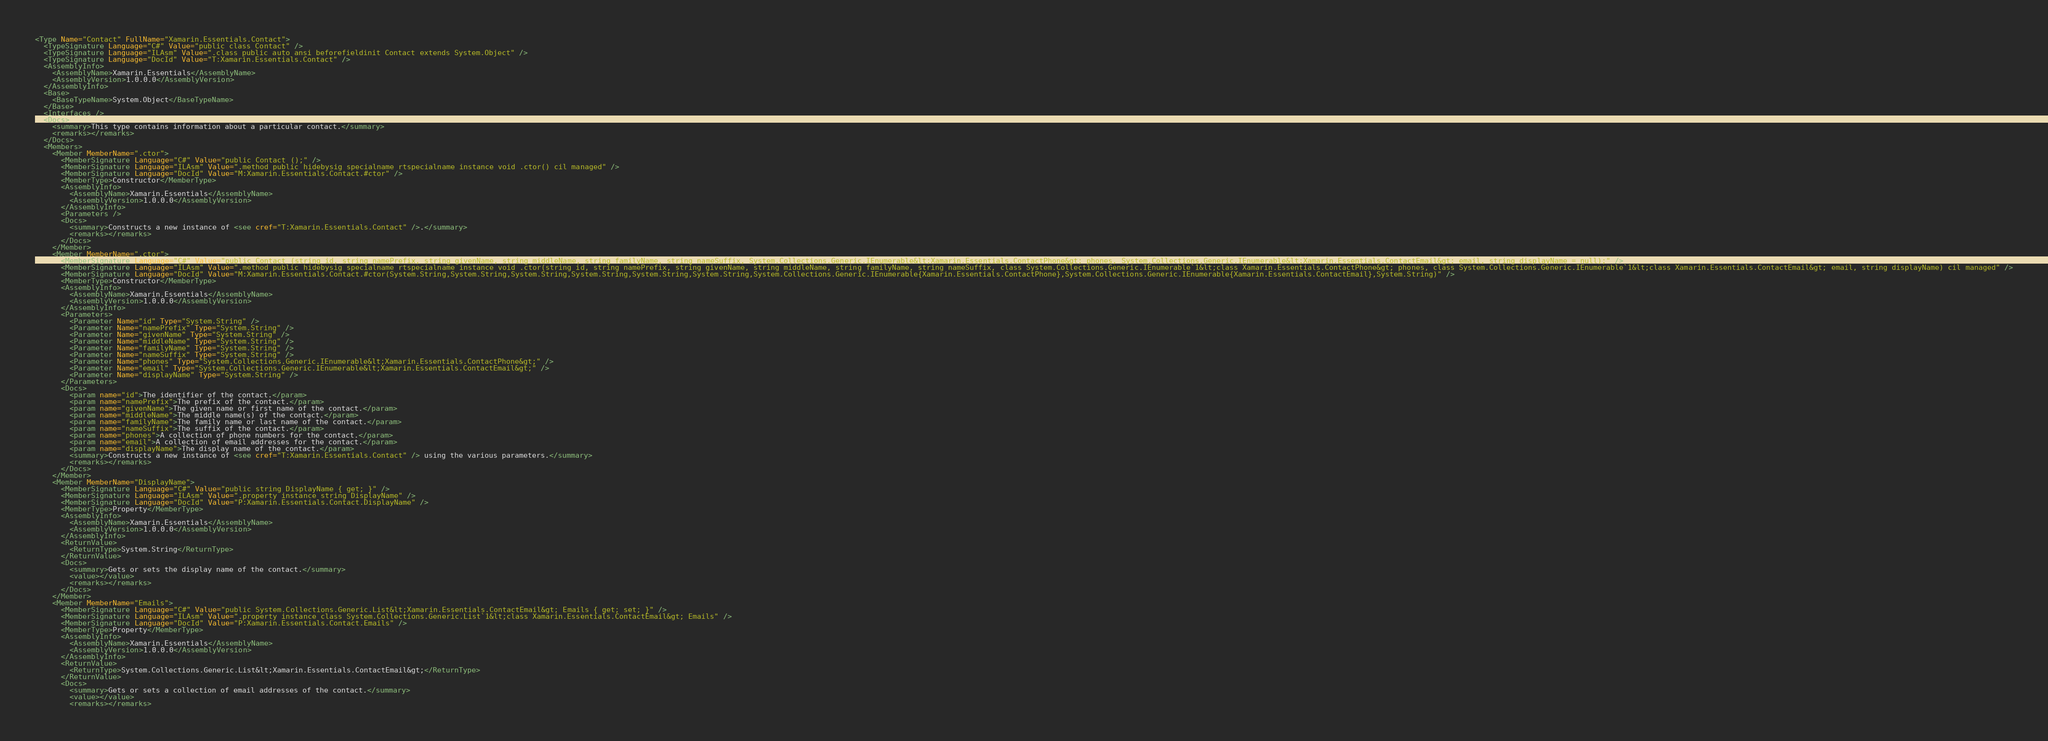<code> <loc_0><loc_0><loc_500><loc_500><_XML_><Type Name="Contact" FullName="Xamarin.Essentials.Contact">
  <TypeSignature Language="C#" Value="public class Contact" />
  <TypeSignature Language="ILAsm" Value=".class public auto ansi beforefieldinit Contact extends System.Object" />
  <TypeSignature Language="DocId" Value="T:Xamarin.Essentials.Contact" />
  <AssemblyInfo>
    <AssemblyName>Xamarin.Essentials</AssemblyName>
    <AssemblyVersion>1.0.0.0</AssemblyVersion>
  </AssemblyInfo>
  <Base>
    <BaseTypeName>System.Object</BaseTypeName>
  </Base>
  <Interfaces />
  <Docs>
    <summary>This type contains information about a particular contact.</summary>
    <remarks></remarks>
  </Docs>
  <Members>
    <Member MemberName=".ctor">
      <MemberSignature Language="C#" Value="public Contact ();" />
      <MemberSignature Language="ILAsm" Value=".method public hidebysig specialname rtspecialname instance void .ctor() cil managed" />
      <MemberSignature Language="DocId" Value="M:Xamarin.Essentials.Contact.#ctor" />
      <MemberType>Constructor</MemberType>
      <AssemblyInfo>
        <AssemblyName>Xamarin.Essentials</AssemblyName>
        <AssemblyVersion>1.0.0.0</AssemblyVersion>
      </AssemblyInfo>
      <Parameters />
      <Docs>
        <summary>Constructs a new instance of <see cref="T:Xamarin.Essentials.Contact" />.</summary>
        <remarks></remarks>
      </Docs>
    </Member>
    <Member MemberName=".ctor">
      <MemberSignature Language="C#" Value="public Contact (string id, string namePrefix, string givenName, string middleName, string familyName, string nameSuffix, System.Collections.Generic.IEnumerable&lt;Xamarin.Essentials.ContactPhone&gt; phones, System.Collections.Generic.IEnumerable&lt;Xamarin.Essentials.ContactEmail&gt; email, string displayName = null);" />
      <MemberSignature Language="ILAsm" Value=".method public hidebysig specialname rtspecialname instance void .ctor(string id, string namePrefix, string givenName, string middleName, string familyName, string nameSuffix, class System.Collections.Generic.IEnumerable`1&lt;class Xamarin.Essentials.ContactPhone&gt; phones, class System.Collections.Generic.IEnumerable`1&lt;class Xamarin.Essentials.ContactEmail&gt; email, string displayName) cil managed" />
      <MemberSignature Language="DocId" Value="M:Xamarin.Essentials.Contact.#ctor(System.String,System.String,System.String,System.String,System.String,System.String,System.Collections.Generic.IEnumerable{Xamarin.Essentials.ContactPhone},System.Collections.Generic.IEnumerable{Xamarin.Essentials.ContactEmail},System.String)" />
      <MemberType>Constructor</MemberType>
      <AssemblyInfo>
        <AssemblyName>Xamarin.Essentials</AssemblyName>
        <AssemblyVersion>1.0.0.0</AssemblyVersion>
      </AssemblyInfo>
      <Parameters>
        <Parameter Name="id" Type="System.String" />
        <Parameter Name="namePrefix" Type="System.String" />
        <Parameter Name="givenName" Type="System.String" />
        <Parameter Name="middleName" Type="System.String" />
        <Parameter Name="familyName" Type="System.String" />
        <Parameter Name="nameSuffix" Type="System.String" />
        <Parameter Name="phones" Type="System.Collections.Generic.IEnumerable&lt;Xamarin.Essentials.ContactPhone&gt;" />
        <Parameter Name="email" Type="System.Collections.Generic.IEnumerable&lt;Xamarin.Essentials.ContactEmail&gt;" />
        <Parameter Name="displayName" Type="System.String" />
      </Parameters>
      <Docs>
        <param name="id">The identifier of the contact.</param>
        <param name="namePrefix">The prefix of the contact.</param>
        <param name="givenName">The given name or first name of the contact.</param>
        <param name="middleName">The middle name(s) of the contact.</param>
        <param name="familyName">The family name or last name of the contact.</param>
        <param name="nameSuffix">The suffix of the contact.</param>
        <param name="phones">A collection of phone numbers for the contact.</param>
        <param name="email">A collection of email addresses for the contact.</param>
        <param name="displayName">The display name of the contact.</param>
        <summary>Constructs a new instance of <see cref="T:Xamarin.Essentials.Contact" /> using the various parameters.</summary>
        <remarks></remarks>
      </Docs>
    </Member>
    <Member MemberName="DisplayName">
      <MemberSignature Language="C#" Value="public string DisplayName { get; }" />
      <MemberSignature Language="ILAsm" Value=".property instance string DisplayName" />
      <MemberSignature Language="DocId" Value="P:Xamarin.Essentials.Contact.DisplayName" />
      <MemberType>Property</MemberType>
      <AssemblyInfo>
        <AssemblyName>Xamarin.Essentials</AssemblyName>
        <AssemblyVersion>1.0.0.0</AssemblyVersion>
      </AssemblyInfo>
      <ReturnValue>
        <ReturnType>System.String</ReturnType>
      </ReturnValue>
      <Docs>
        <summary>Gets or sets the display name of the contact.</summary>
        <value></value>
        <remarks></remarks>
      </Docs>
    </Member>
    <Member MemberName="Emails">
      <MemberSignature Language="C#" Value="public System.Collections.Generic.List&lt;Xamarin.Essentials.ContactEmail&gt; Emails { get; set; }" />
      <MemberSignature Language="ILAsm" Value=".property instance class System.Collections.Generic.List`1&lt;class Xamarin.Essentials.ContactEmail&gt; Emails" />
      <MemberSignature Language="DocId" Value="P:Xamarin.Essentials.Contact.Emails" />
      <MemberType>Property</MemberType>
      <AssemblyInfo>
        <AssemblyName>Xamarin.Essentials</AssemblyName>
        <AssemblyVersion>1.0.0.0</AssemblyVersion>
      </AssemblyInfo>
      <ReturnValue>
        <ReturnType>System.Collections.Generic.List&lt;Xamarin.Essentials.ContactEmail&gt;</ReturnType>
      </ReturnValue>
      <Docs>
        <summary>Gets or sets a collection of email addresses of the contact.</summary>
        <value></value>
        <remarks></remarks></code> 